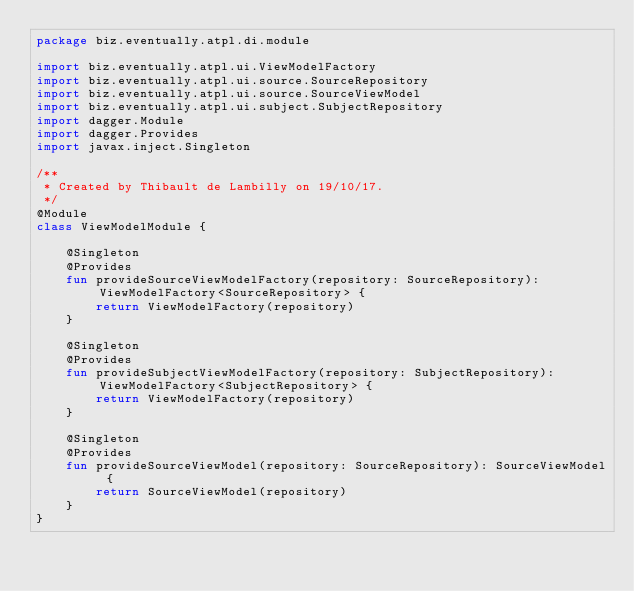<code> <loc_0><loc_0><loc_500><loc_500><_Kotlin_>package biz.eventually.atpl.di.module

import biz.eventually.atpl.ui.ViewModelFactory
import biz.eventually.atpl.ui.source.SourceRepository
import biz.eventually.atpl.ui.source.SourceViewModel
import biz.eventually.atpl.ui.subject.SubjectRepository
import dagger.Module
import dagger.Provides
import javax.inject.Singleton

/**
 * Created by Thibault de Lambilly on 19/10/17.
 */
@Module
class ViewModelModule {

    @Singleton
    @Provides
    fun provideSourceViewModelFactory(repository: SourceRepository): ViewModelFactory<SourceRepository> {
        return ViewModelFactory(repository)
    }

    @Singleton
    @Provides
    fun provideSubjectViewModelFactory(repository: SubjectRepository): ViewModelFactory<SubjectRepository> {
        return ViewModelFactory(repository)
    }

    @Singleton
    @Provides
    fun provideSourceViewModel(repository: SourceRepository): SourceViewModel {
        return SourceViewModel(repository)
    }
}</code> 